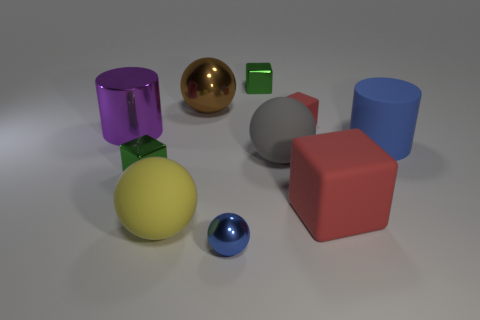Subtract all cylinders. How many objects are left? 8 Subtract 0 green spheres. How many objects are left? 10 Subtract all large brown metal spheres. Subtract all big blue things. How many objects are left? 8 Add 8 large gray spheres. How many large gray spheres are left? 9 Add 10 yellow matte cylinders. How many yellow matte cylinders exist? 10 